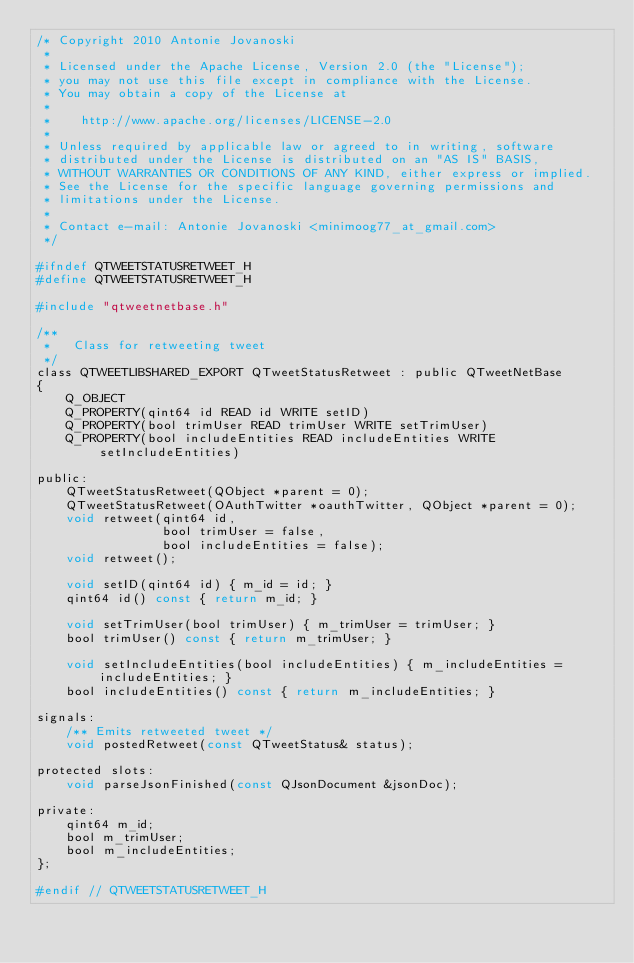<code> <loc_0><loc_0><loc_500><loc_500><_C_>/* Copyright 2010 Antonie Jovanoski
 *
 * Licensed under the Apache License, Version 2.0 (the "License");
 * you may not use this file except in compliance with the License.
 * You may obtain a copy of the License at
 *
 *    http://www.apache.org/licenses/LICENSE-2.0
 *
 * Unless required by applicable law or agreed to in writing, software
 * distributed under the License is distributed on an "AS IS" BASIS,
 * WITHOUT WARRANTIES OR CONDITIONS OF ANY KIND, either express or implied.
 * See the License for the specific language governing permissions and
 * limitations under the License.
 *
 * Contact e-mail: Antonie Jovanoski <minimoog77_at_gmail.com>
 */

#ifndef QTWEETSTATUSRETWEET_H
#define QTWEETSTATUSRETWEET_H

#include "qtweetnetbase.h"

/**
 *   Class for retweeting tweet
 */
class QTWEETLIBSHARED_EXPORT QTweetStatusRetweet : public QTweetNetBase
{
    Q_OBJECT
    Q_PROPERTY(qint64 id READ id WRITE setID)
    Q_PROPERTY(bool trimUser READ trimUser WRITE setTrimUser)
    Q_PROPERTY(bool includeEntities READ includeEntities WRITE setIncludeEntities)

public:
    QTweetStatusRetweet(QObject *parent = 0);
    QTweetStatusRetweet(OAuthTwitter *oauthTwitter, QObject *parent = 0);
    void retweet(qint64 id,
                 bool trimUser = false,
                 bool includeEntities = false);
    void retweet();

    void setID(qint64 id) { m_id = id; }
    qint64 id() const { return m_id; }

    void setTrimUser(bool trimUser) { m_trimUser = trimUser; }
    bool trimUser() const { return m_trimUser; }

    void setIncludeEntities(bool includeEntities) { m_includeEntities = includeEntities; }
    bool includeEntities() const { return m_includeEntities; }

signals:
    /** Emits retweeted tweet */
    void postedRetweet(const QTweetStatus& status);

protected slots:
    void parseJsonFinished(const QJsonDocument &jsonDoc);

private:
    qint64 m_id;
    bool m_trimUser;
    bool m_includeEntities;
};

#endif // QTWEETSTATUSRETWEET_H
</code> 